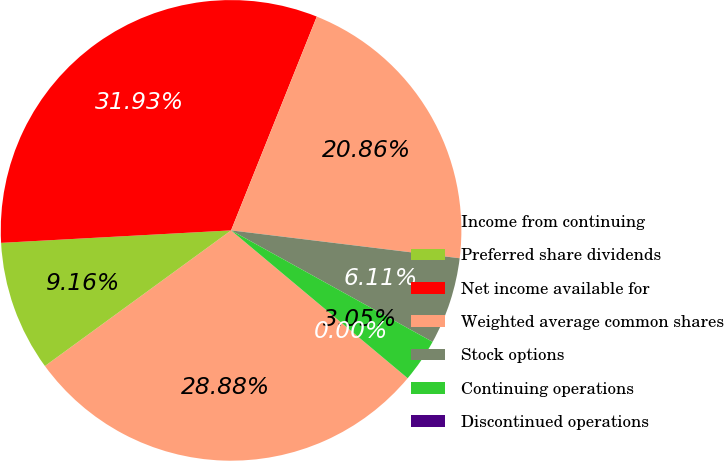<chart> <loc_0><loc_0><loc_500><loc_500><pie_chart><fcel>Income from continuing<fcel>Preferred share dividends<fcel>Net income available for<fcel>Weighted average common shares<fcel>Stock options<fcel>Continuing operations<fcel>Discontinued operations<nl><fcel>28.88%<fcel>9.16%<fcel>31.93%<fcel>20.86%<fcel>6.11%<fcel>3.05%<fcel>0.0%<nl></chart> 